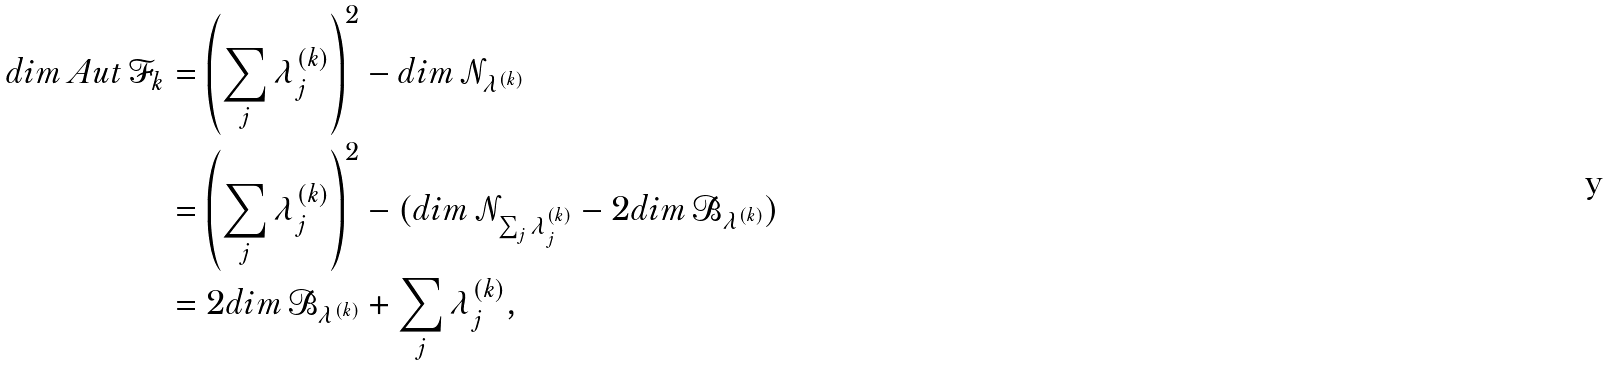<formula> <loc_0><loc_0><loc_500><loc_500>d i m \, A u t \, \mathcal { F } _ { k } & = \left ( \sum _ { j } \lambda ^ { ( k ) } _ { j } \right ) ^ { 2 } - d i m \, \mathcal { N } _ { \lambda ^ { ( k ) } } \\ & = \left ( \sum _ { j } \lambda ^ { ( k ) } _ { j } \right ) ^ { 2 } - ( d i m \, \mathcal { N } _ { \sum _ { j } \lambda ^ { ( k ) } _ { j } } - 2 d i m \, \mathcal { B } _ { \lambda ^ { ( k ) } } ) \\ & = 2 d i m \, \mathcal { B } _ { \lambda ^ { ( k ) } } + \sum _ { j } \lambda ^ { ( k ) } _ { j } ,</formula> 